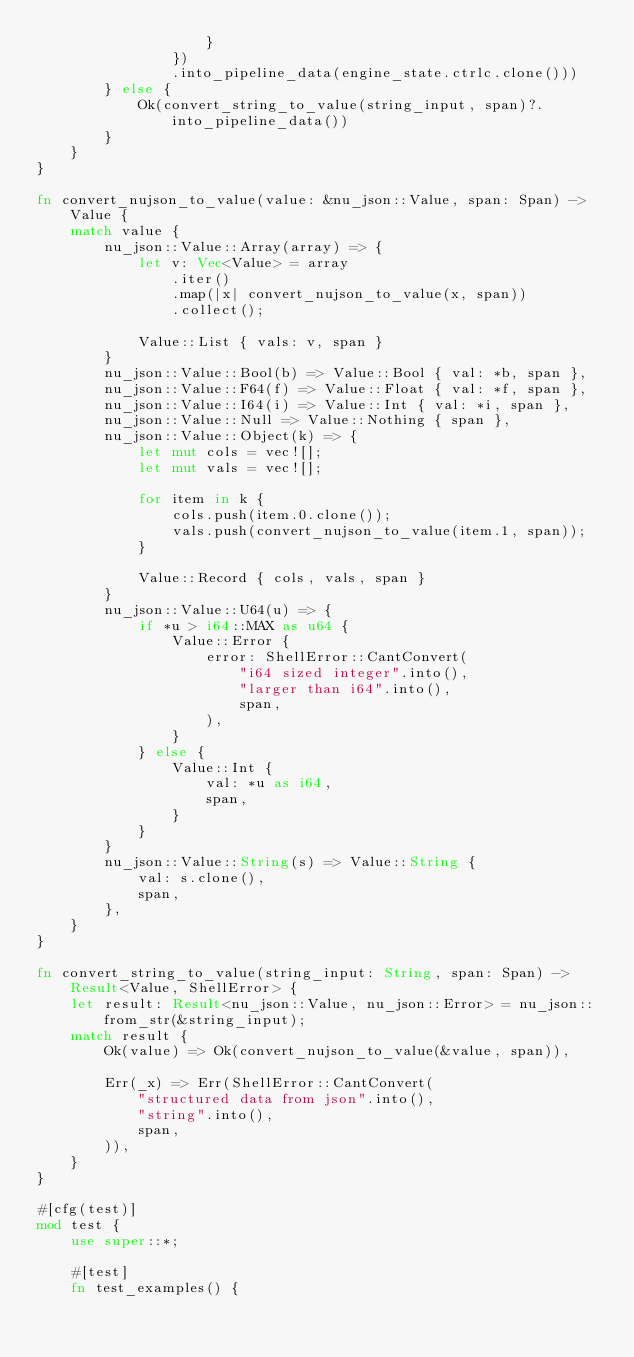Convert code to text. <code><loc_0><loc_0><loc_500><loc_500><_Rust_>                    }
                })
                .into_pipeline_data(engine_state.ctrlc.clone()))
        } else {
            Ok(convert_string_to_value(string_input, span)?.into_pipeline_data())
        }
    }
}

fn convert_nujson_to_value(value: &nu_json::Value, span: Span) -> Value {
    match value {
        nu_json::Value::Array(array) => {
            let v: Vec<Value> = array
                .iter()
                .map(|x| convert_nujson_to_value(x, span))
                .collect();

            Value::List { vals: v, span }
        }
        nu_json::Value::Bool(b) => Value::Bool { val: *b, span },
        nu_json::Value::F64(f) => Value::Float { val: *f, span },
        nu_json::Value::I64(i) => Value::Int { val: *i, span },
        nu_json::Value::Null => Value::Nothing { span },
        nu_json::Value::Object(k) => {
            let mut cols = vec![];
            let mut vals = vec![];

            for item in k {
                cols.push(item.0.clone());
                vals.push(convert_nujson_to_value(item.1, span));
            }

            Value::Record { cols, vals, span }
        }
        nu_json::Value::U64(u) => {
            if *u > i64::MAX as u64 {
                Value::Error {
                    error: ShellError::CantConvert(
                        "i64 sized integer".into(),
                        "larger than i64".into(),
                        span,
                    ),
                }
            } else {
                Value::Int {
                    val: *u as i64,
                    span,
                }
            }
        }
        nu_json::Value::String(s) => Value::String {
            val: s.clone(),
            span,
        },
    }
}

fn convert_string_to_value(string_input: String, span: Span) -> Result<Value, ShellError> {
    let result: Result<nu_json::Value, nu_json::Error> = nu_json::from_str(&string_input);
    match result {
        Ok(value) => Ok(convert_nujson_to_value(&value, span)),

        Err(_x) => Err(ShellError::CantConvert(
            "structured data from json".into(),
            "string".into(),
            span,
        )),
    }
}

#[cfg(test)]
mod test {
    use super::*;

    #[test]
    fn test_examples() {</code> 